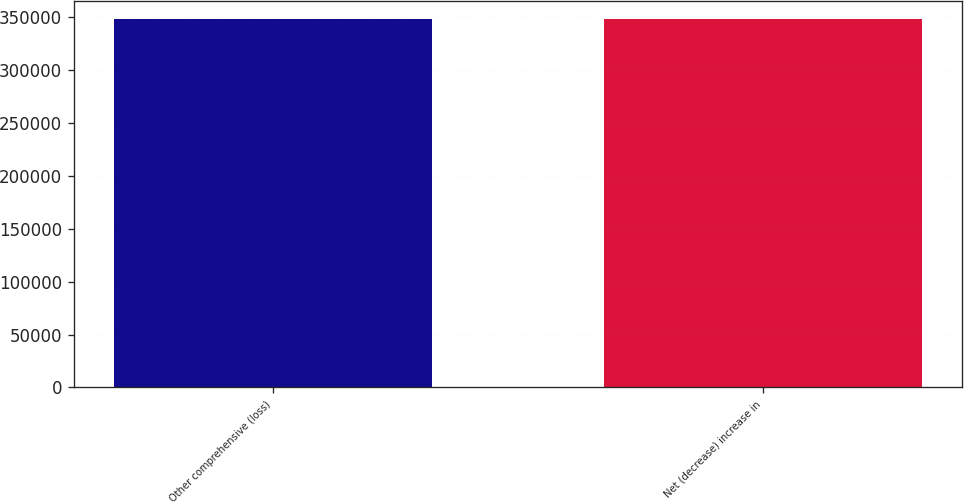<chart> <loc_0><loc_0><loc_500><loc_500><bar_chart><fcel>Other comprehensive (loss)<fcel>Net (decrease) increase in<nl><fcel>347952<fcel>347952<nl></chart> 